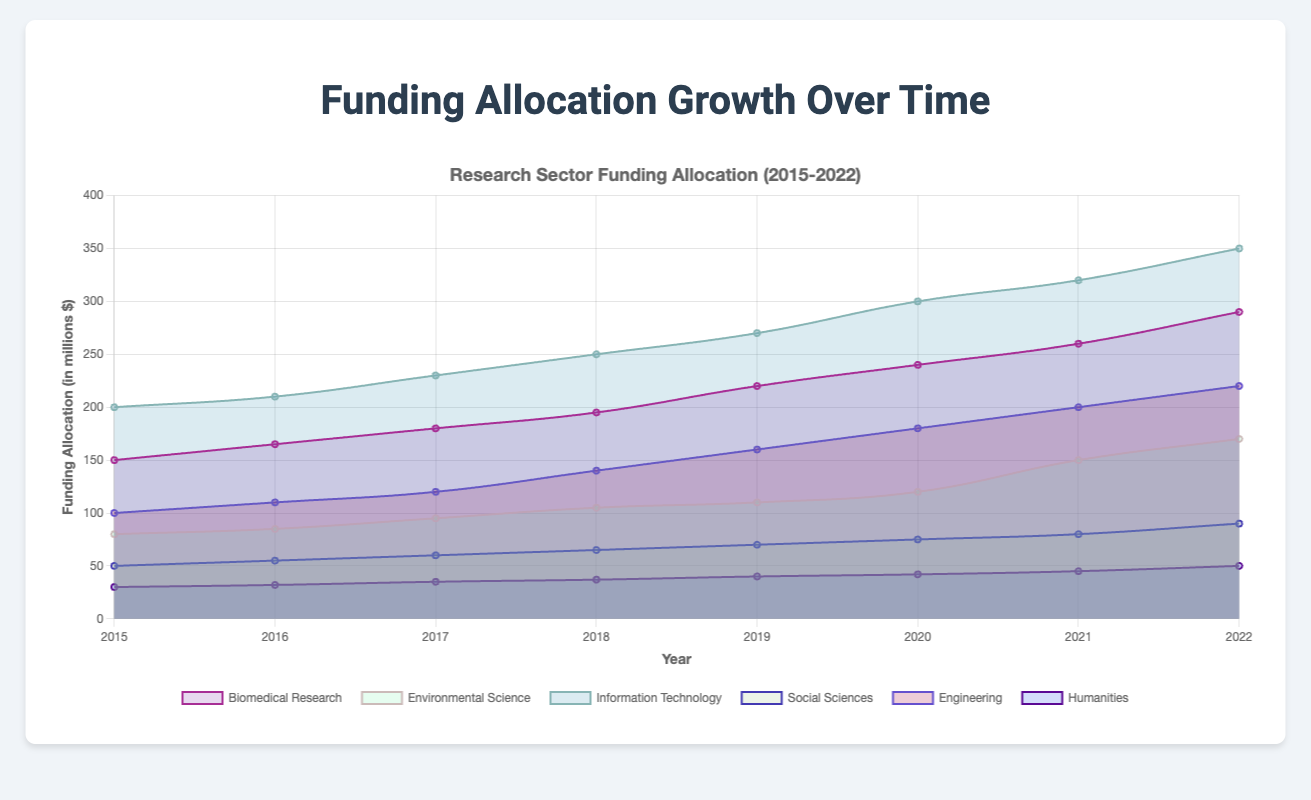What is the title of the chart? The title is usually found at the top of the chart, prominently displayed to indicate what the chart is about. In this case, it's "Funding Allocation Growth Over Time".
Answer: Funding Allocation Growth Over Time How many research sectors are represented in the chart? To find the number of research sectors, look at the legend or the labels corresponding to the different colored areas within the chart. Each sector is represented by a distinct label. Count these labels.
Answer: 6 Which research sector received the most funding in 2022? Identify the highest point on the y-axis for the year 2022. Then, refer to the chart legend to see which color represents the corresponding sector.
Answer: Information Technology What is the total funding allocation for Engineering in the years 2015-2018? Sum the funding allocations for Engineering from 2015 to 2018: 100 (2015) + 110 (2016) + 120 (2017) + 140 (2018) = 470 million.
Answer: 470 million Which two research sectors had the closest funding allocations in 2017, and what were they? Observe the y-axis values for each sector at the year 2017. Compare these values to see which two are the closest. Biomedical Research and Environmental Science have allocations of 180 and 95 million respectively, but Environmental Science and Social Sciences are closer (95 and 60 million).
Answer: Environmental Science and Social Sciences, 95 and 60 million By how much did the funding in Information Technology increase from 2015 to 2022? Subtract the funding amount for Information Technology in 2015 from the amount in 2022: 350 (2022) - 200 (2015) = 150 million.
Answer: 150 million Which research sector saw the least growth from 2015 to 2022? Calculate the growth for each sector by subtracting the 2015 funding from the 2022 funding. Compare these values to determine the smallest growth. Humanities grew from 30 to 50 million, which is 20 million.
Answer: Humanities In which year did Biomedical Research experience the highest annual increase in funding? Calculate the annual differences in funding for Biomedical Research and identify the year with the highest increase: (165-150)=15, (180-165)=15, (195-180)=15, (220-195)=25, (240-220)=20, (260-240)=20, (290-260)=30. The highest increase was between 2021 and 2022.
Answer: 2022 Which sector had the sharpest decline in funding in any given year, if any? Reviewing the chart, none of the sectors appear to have a decline, since all lines are increasive over the years.
Answer: None Did Social Sciences ever surpass Environmental Science in funding over the years? Compare the y-axis values for Social Sciences and Environmental Science for each year. Social Sciences consistently had lower funding than Environmental Science throughout the period.
Answer: No 